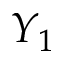<formula> <loc_0><loc_0><loc_500><loc_500>Y _ { 1 }</formula> 